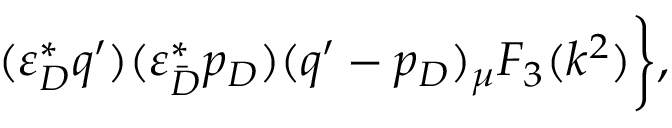<formula> <loc_0><loc_0><loc_500><loc_500>( \varepsilon _ { D } ^ { * } q ^ { \prime } ) ( \varepsilon _ { \bar { D } } ^ { * } p _ { D } ) ( q ^ { \prime } - p _ { D } ) _ { \mu } F _ { 3 } ( k ^ { 2 } ) \Big \} ,</formula> 